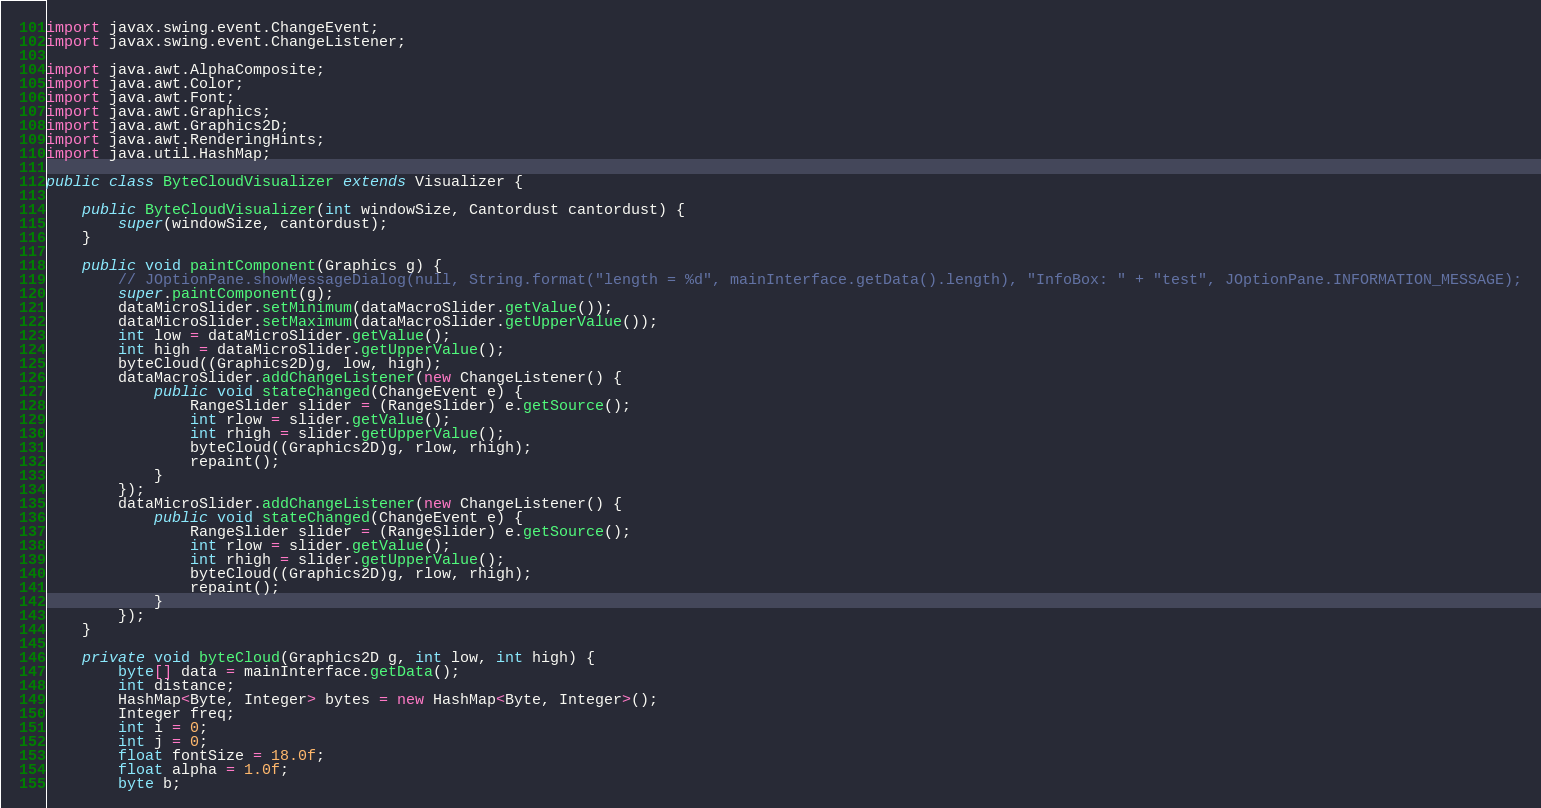Convert code to text. <code><loc_0><loc_0><loc_500><loc_500><_Java_>import javax.swing.event.ChangeEvent;
import javax.swing.event.ChangeListener;

import java.awt.AlphaComposite;
import java.awt.Color;
import java.awt.Font;
import java.awt.Graphics;
import java.awt.Graphics2D;
import java.awt.RenderingHints;
import java.util.HashMap;

public class ByteCloudVisualizer extends Visualizer {

    public ByteCloudVisualizer(int windowSize, Cantordust cantordust) {
        super(windowSize, cantordust);
    }

    public void paintComponent(Graphics g) {
        // JOptionPane.showMessageDialog(null, String.format("length = %d", mainInterface.getData().length), "InfoBox: " + "test", JOptionPane.INFORMATION_MESSAGE);
        super.paintComponent(g);
        dataMicroSlider.setMinimum(dataMacroSlider.getValue());
        dataMicroSlider.setMaximum(dataMacroSlider.getUpperValue());
        int low = dataMicroSlider.getValue();
        int high = dataMicroSlider.getUpperValue();
        byteCloud((Graphics2D)g, low, high);
        dataMacroSlider.addChangeListener(new ChangeListener() {
            public void stateChanged(ChangeEvent e) {
                RangeSlider slider = (RangeSlider) e.getSource();
                int rlow = slider.getValue();
                int rhigh = slider.getUpperValue();
                byteCloud((Graphics2D)g, rlow, rhigh);
                repaint();
            }
        });
        dataMicroSlider.addChangeListener(new ChangeListener() {
            public void stateChanged(ChangeEvent e) {
                RangeSlider slider = (RangeSlider) e.getSource();
                int rlow = slider.getValue();
                int rhigh = slider.getUpperValue();
                byteCloud((Graphics2D)g, rlow, rhigh);
                repaint();
            }
        });
    }

    private void byteCloud(Graphics2D g, int low, int high) {
        byte[] data = mainInterface.getData();
        int distance;
        HashMap<Byte, Integer> bytes = new HashMap<Byte, Integer>();
        Integer freq;
        int i = 0;
        int j = 0;
        float fontSize = 18.0f;
        float alpha = 1.0f;
        byte b;</code> 